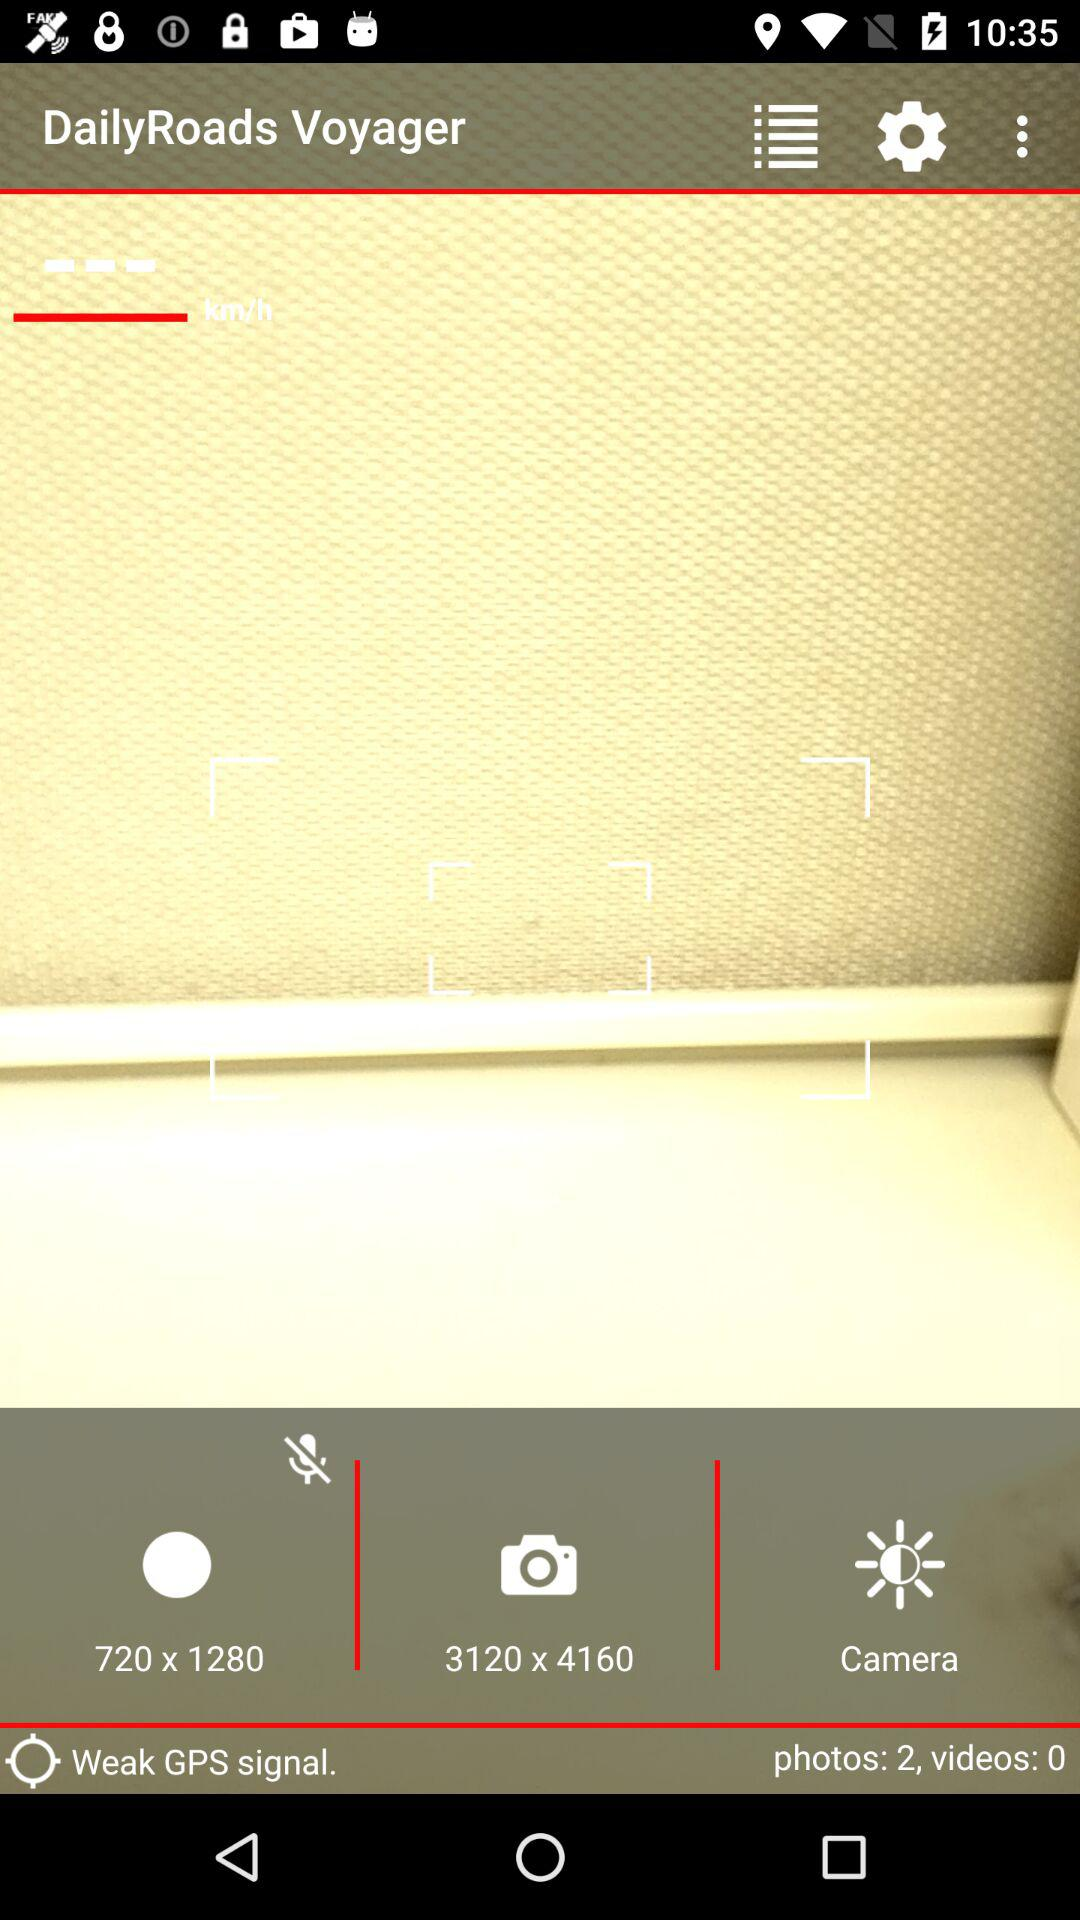How many more photos than videos are there?
Answer the question using a single word or phrase. 2 